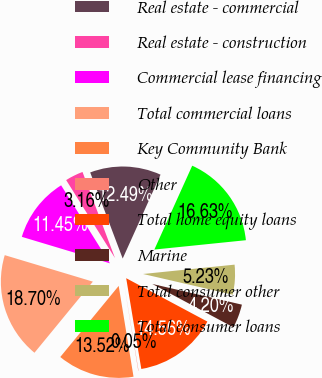<chart> <loc_0><loc_0><loc_500><loc_500><pie_chart><fcel>Real estate - commercial<fcel>Real estate - construction<fcel>Commercial lease financing<fcel>Total commercial loans<fcel>Key Community Bank<fcel>Other<fcel>Total home equity loans<fcel>Marine<fcel>Total consumer other<fcel>Total consumer loans<nl><fcel>12.49%<fcel>3.16%<fcel>11.45%<fcel>18.7%<fcel>13.52%<fcel>0.05%<fcel>14.56%<fcel>4.2%<fcel>5.23%<fcel>16.63%<nl></chart> 